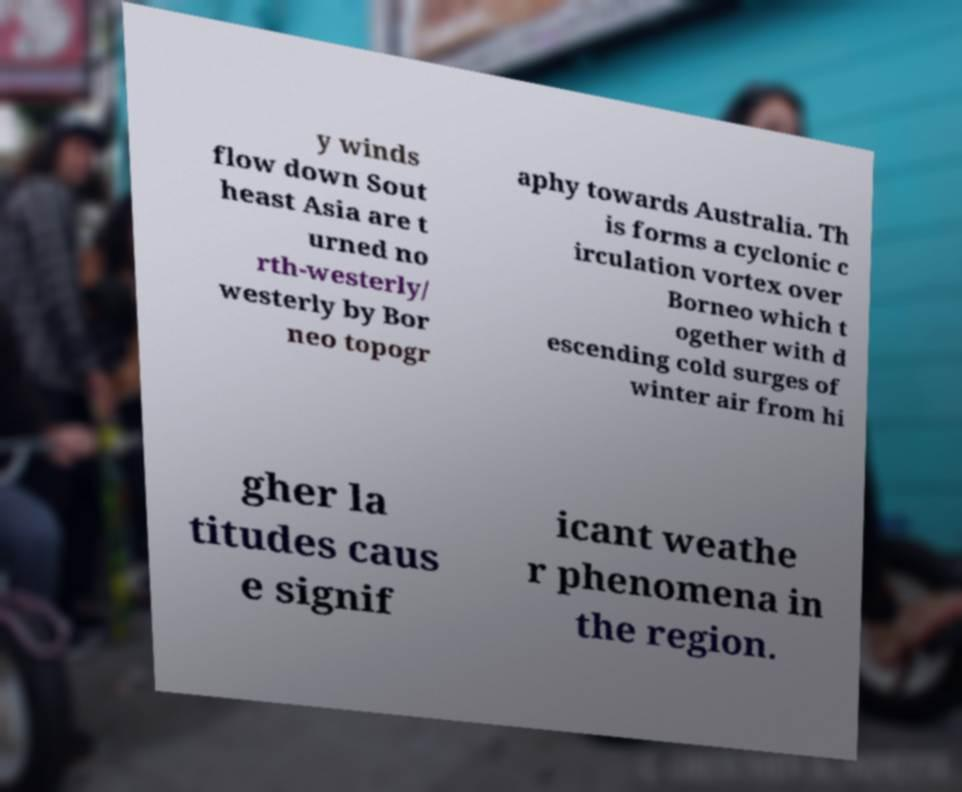Could you assist in decoding the text presented in this image and type it out clearly? y winds flow down Sout heast Asia are t urned no rth-westerly/ westerly by Bor neo topogr aphy towards Australia. Th is forms a cyclonic c irculation vortex over Borneo which t ogether with d escending cold surges of winter air from hi gher la titudes caus e signif icant weathe r phenomena in the region. 